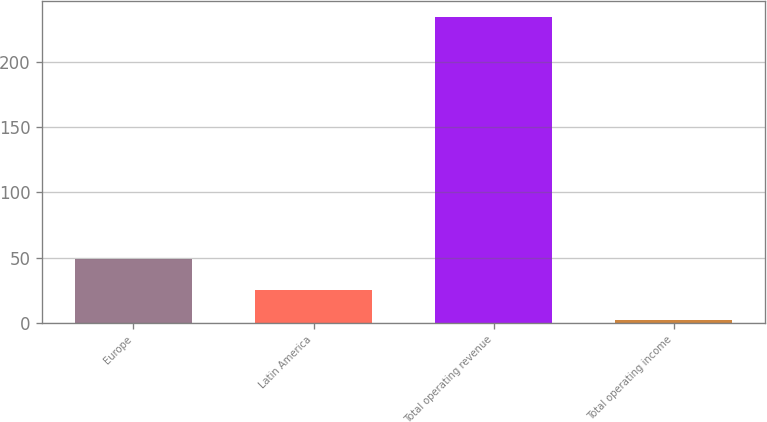Convert chart to OTSL. <chart><loc_0><loc_0><loc_500><loc_500><bar_chart><fcel>Europe<fcel>Latin America<fcel>Total operating revenue<fcel>Total operating income<nl><fcel>48.7<fcel>25.4<fcel>235.1<fcel>2.1<nl></chart> 